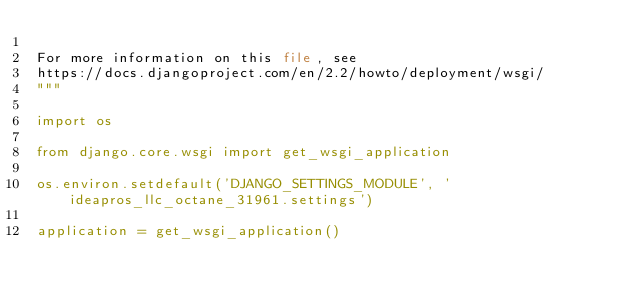<code> <loc_0><loc_0><loc_500><loc_500><_Python_>
For more information on this file, see
https://docs.djangoproject.com/en/2.2/howto/deployment/wsgi/
"""

import os

from django.core.wsgi import get_wsgi_application

os.environ.setdefault('DJANGO_SETTINGS_MODULE', 'ideapros_llc_octane_31961.settings')

application = get_wsgi_application()
</code> 